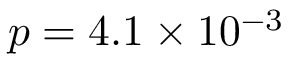Convert formula to latex. <formula><loc_0><loc_0><loc_500><loc_500>p = 4 . 1 \times 1 0 ^ { - 3 }</formula> 